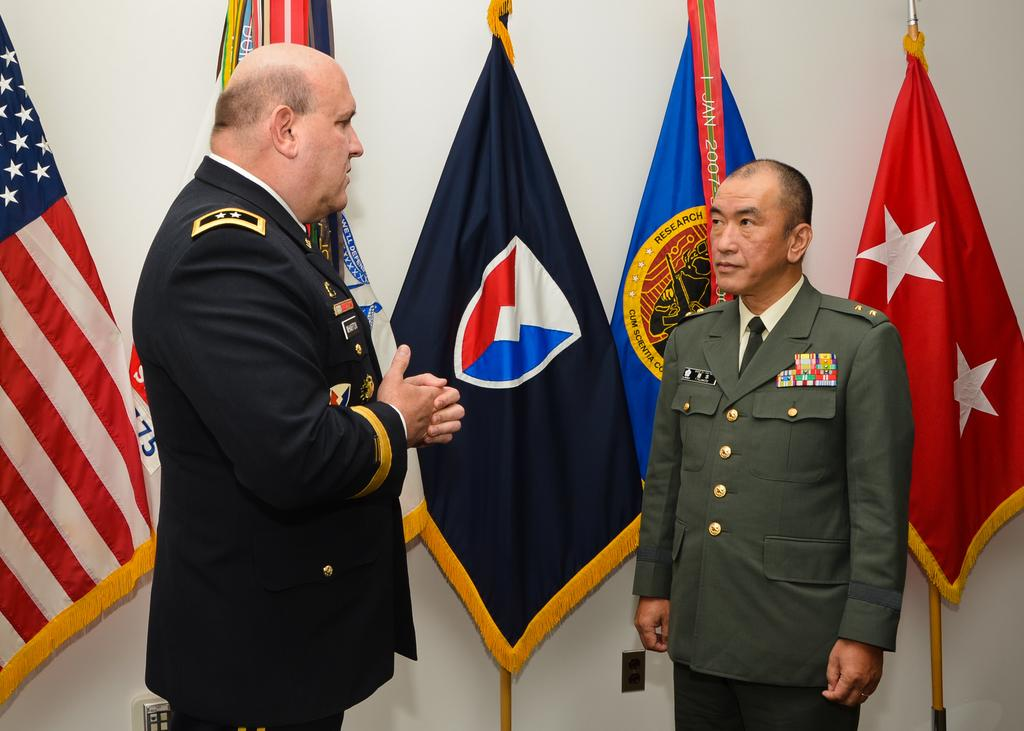How many people are in the image? There are 2 men in the image. What are the men doing in the image? The men are standing. What can be seen in the image besides the men? There are 5 colorful flags in the image. What is visible in the background of the image? There is a white wall in the background of the image. Can you tell me how many thumbs are visible in the image? There is no mention of thumbs in the image, so it is impossible to determine how many are visible. 